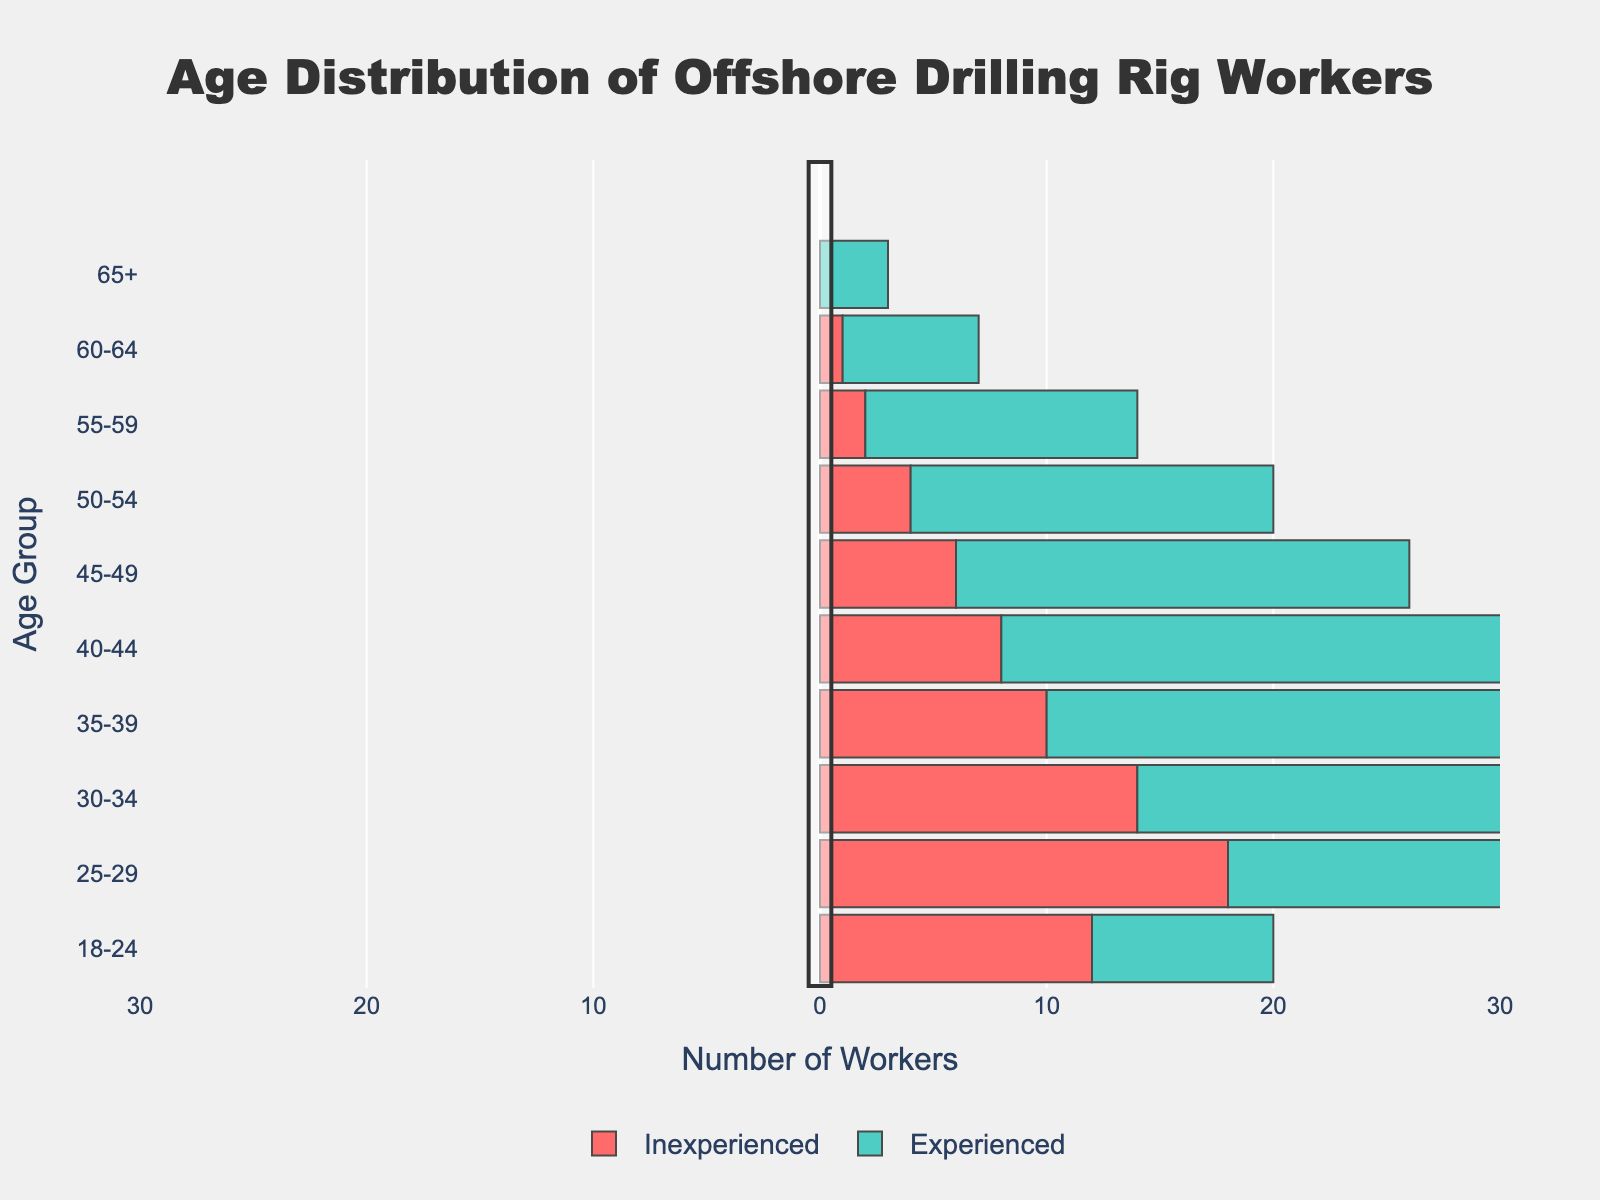What's the title of the figure? The title is displayed at the top center of the figure, which reads "Age Distribution of Offshore Drilling Rig Workers."
Answer: Age Distribution of Offshore Drilling Rig Workers What is the color used to represent inexperienced workers in the figure? Inexperienced workers are shown by bars colored in a shade of red.
Answer: Red Which age group has the highest number of inexperienced workers? By examining the length of the red bars for each age group, the 25-29 age group has the longest bar, indicating the highest number of inexperienced workers.
Answer: 25-29 How many experienced workers are there in the 35-39 age group? The number of experienced workers in the 35-39 age group is represented by the green bar heading left, which reaches -28. Thus, there are 28 experienced workers.
Answer: 28 What's the difference in the number of workers between the 50-54 age group and the 55-59 age group for inexperienced workers? The number of inexperienced workers in the 50-54 age group is 4, while in the 55-59 age group it is 2. The difference is 4 - 2 = 2.
Answer: 2 Which age group has a greater number of total workers, 18-24 or 45-49? For the 18-24 age group: 12 inexperienced + 8 experienced = 20. For the 45-49 age group: 6 inexperienced + 20 experienced = 26. Therefore, the 45-49 age group has a greater total number of workers.
Answer: 45-49 What's the combined number of experienced workers in the age groups 40-44 and 50-54? For 40-44, the number of experienced workers is 25. For 50-54, it is 16. Therefore, the combined number is 25 + 16 = 41.
Answer: 41 Which side has higher numbers overall, inexperienced workers or experienced workers? Count the total number of workers on each side. For inexperienced: 12 + 18 + 14 + 10 + 8 + 6 + 4 + 2 + 1 + 0 = 75. For experienced: 8 + 15 + 22 + 28 + 25 + 20 + 16 + 12 + 6 + 3 = 155. Experienced workers have higher numbers overall.
Answer: Experienced workers What percentage of the total 30-34 age group is experienced? The total number of workers in the 30-34 age group is 14 (inexperienced) + 22 (experienced) = 36. The percentage of experienced workers is (22 / 36) x 100 = approximately 61.1%.
Answer: 61.1% Which age group has the least number of workers in total? By summing the inexperienced and experienced workers in each age group, the age group with the lowest total is 65+ (0 inexperienced + 3 experienced = 3).
Answer: 65+ 